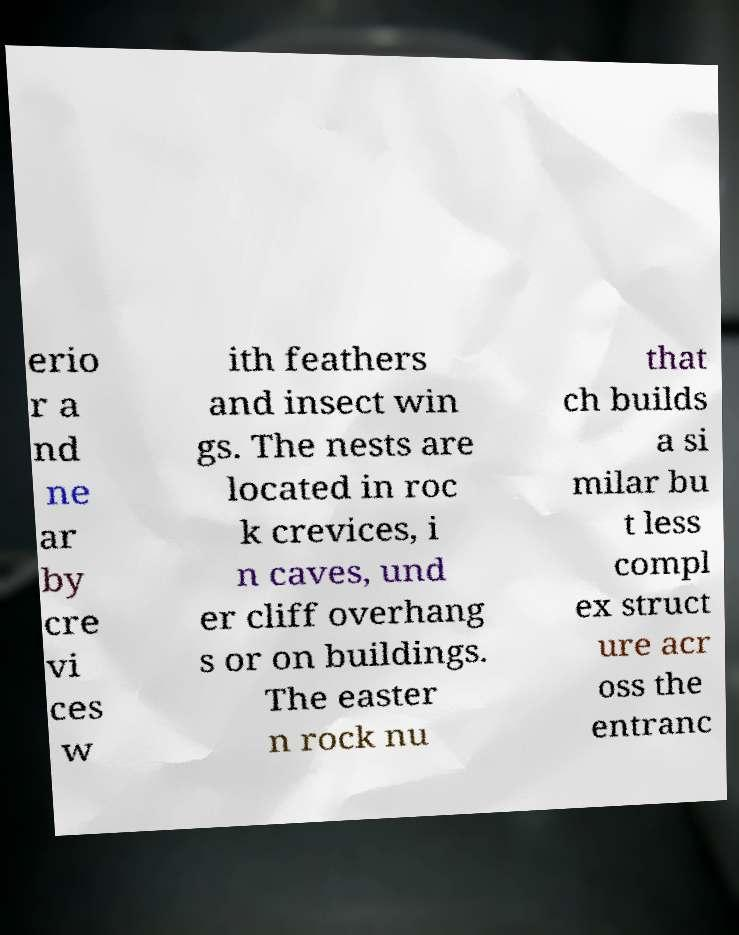What messages or text are displayed in this image? I need them in a readable, typed format. erio r a nd ne ar by cre vi ces w ith feathers and insect win gs. The nests are located in roc k crevices, i n caves, und er cliff overhang s or on buildings. The easter n rock nu that ch builds a si milar bu t less compl ex struct ure acr oss the entranc 